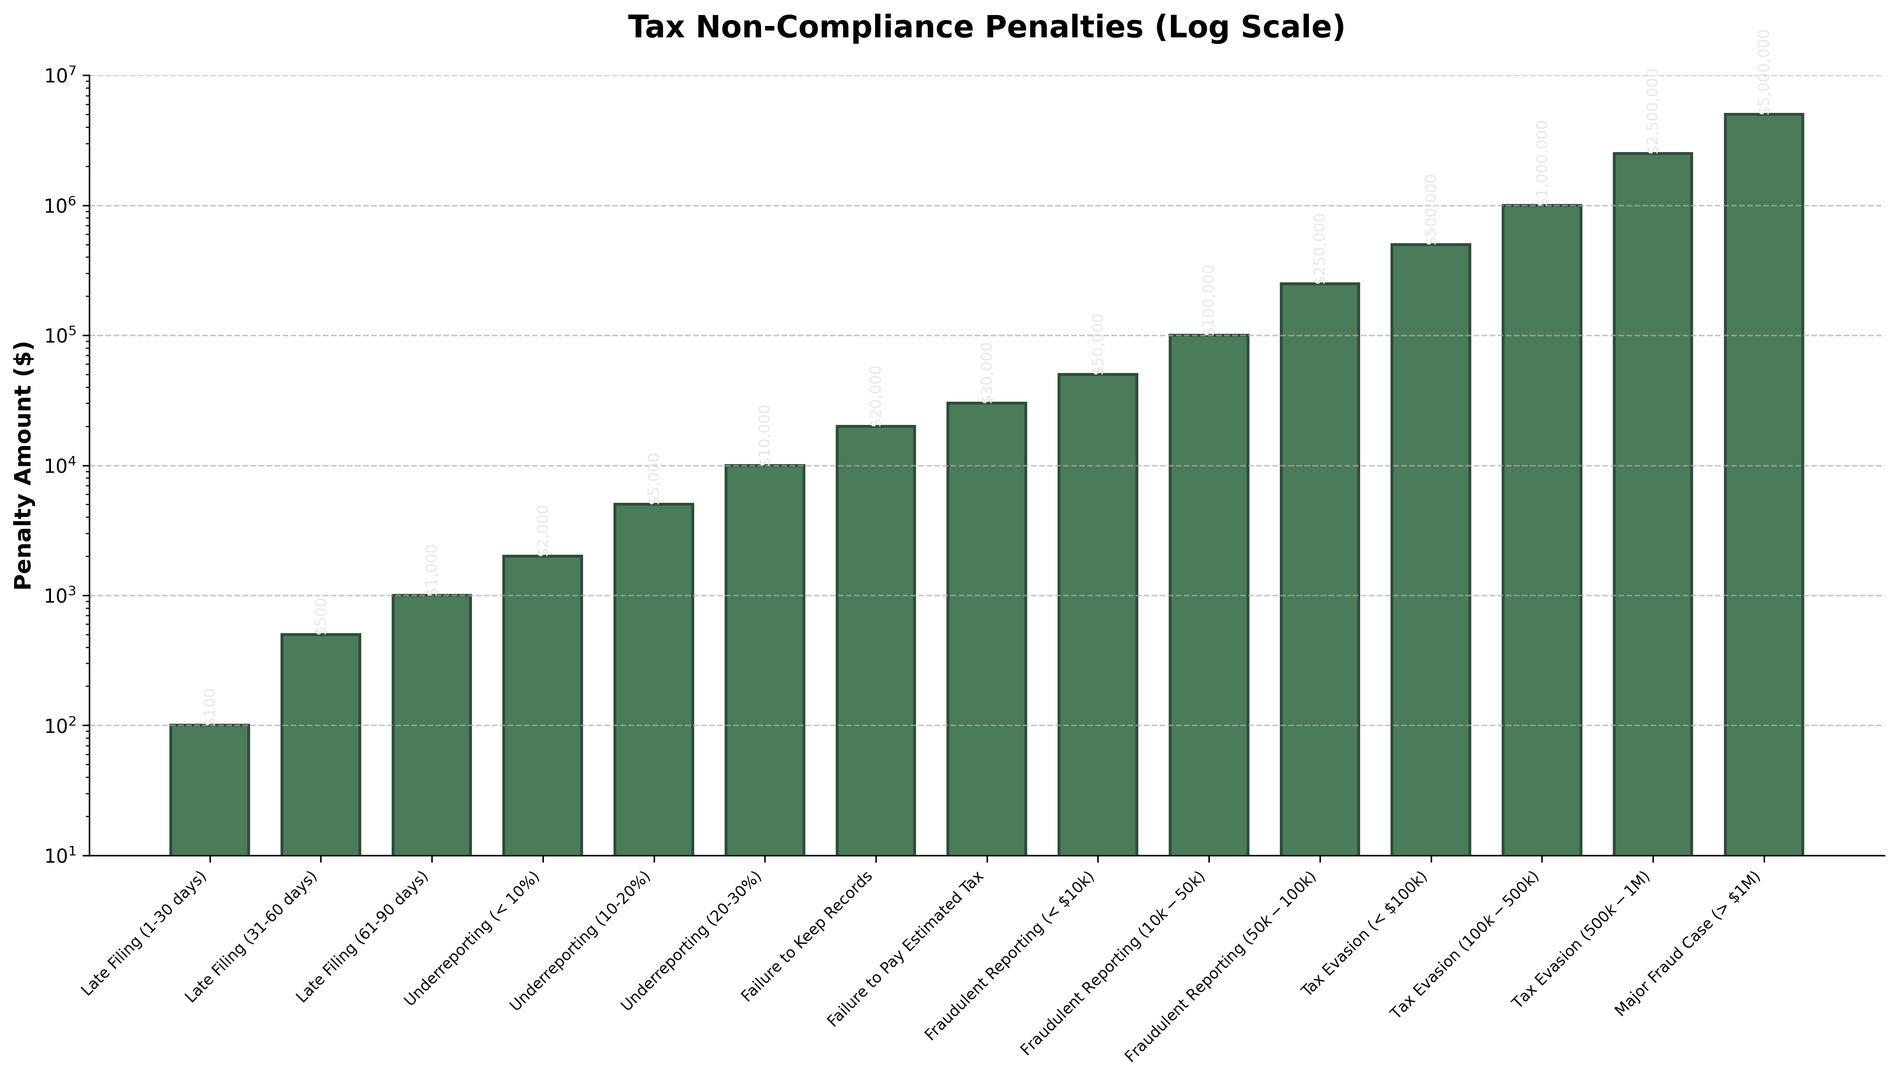What is the penalty amount for Late Filing (31-60 days)? Locate the bar corresponding to 'Late Filing (31-60 days)'. The height of that bar is $500.
Answer: $500 Which type of infraction has the highest penalty amount? Identify the tallest bar in the figure. The 'Major Fraud Case (> $1M)' bar is the tallest.
Answer: Major Fraud Case (> $1M) How does the penalty for Fraudulent Reporting ($10k-$50k) compare to Failure to Pay Estimated Tax? Look at the heights of the bars corresponding to 'Fraudulent Reporting ($10k-$50k)' and 'Failure to Pay Estimated Tax'. The 'Fraudulent Reporting ($10k-$50k)' bar ($100,000) is higher than the 'Failure to Pay Estimated Tax' bar ($30,000).
Answer: The penalty is higher for Fraudulent Reporting ($10k-$50k) What is the total penalty amount for all types of Underreporting? Identify the bars for Underreporting (< 10%), Underreporting (10-20%), and Underreporting (20-30%). Sum their heights: $2000 + $5000 + $10,000 = $17,000.
Answer: $17,000 What is the difference in penalty amounts between Tax Evasion ($500k-$1M) and Tax Evasion (< $100k)? Find the heights of the 'Tax Evasion ($500k-$1M)' and 'Tax Evasion (< $100k)' bars and subtract them: $2,500,000 - $500,000 = $2,000,000.
Answer: $2,000,000 What is the median penalty amount for all infractions listed? Arrange all penalty amounts from smallest to largest and find the middle value. The penalty amounts in order are: 100, 500, 1000, 2000, 5000, 10000, 20000, 30000, 50000, 100000, 250000, 500000, 1000000, 2500000, 5000000. The middle value is $30,000.
Answer: $30,000 Which infraction type has a penalty amount closest to $10,000? Compare all penalty amounts to $10,000 and find the closest value. 'Underreporting (20-30%)' has a penalty of $10,000, which is exactly $10,000.
Answer: Underreporting (20-30%) Compare the penalties for the three types of Late Filing. Which is the highest? Examine the bars for 'Late Filing (1-30 days)', 'Late Filing (31-60 days)' and 'Late Filing (61-90 days)'. The heights are $100, $500, and $1000 respectively. The highest is $1000 for 'Late Filing (61-90 days)'.
Answer: Late Filing (61-90 days) How much higher is the penalty for Failure to Keep Records compared to Late Filing (61-90 days)? Subtract the penalty for 'Late Filing (61-90 days)' ($1000) from the penalty for 'Failure to Keep Records' ($20,000). The difference is $20,000 - $1000 = $19,000.
Answer: $19,000 